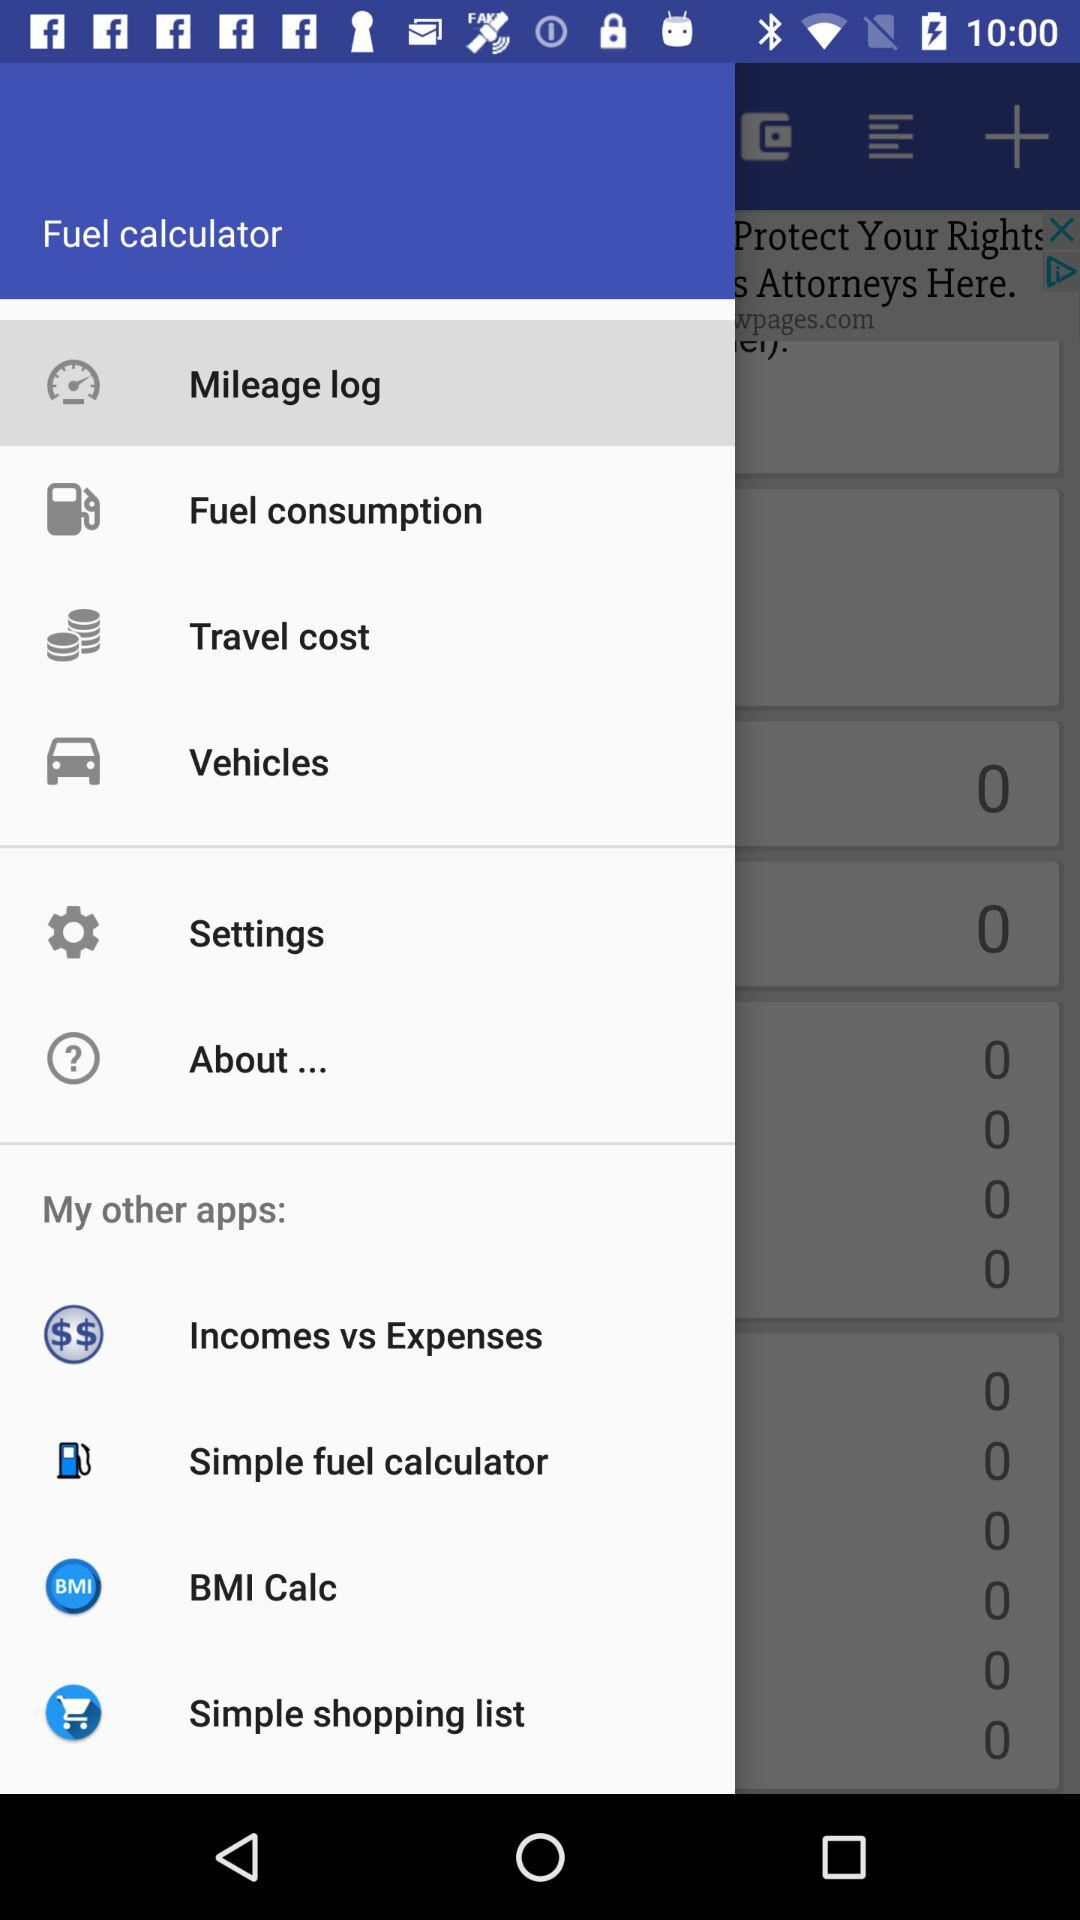What are the available items? The available items are "Mileage log", "Fuel consumption", "Travel cost", "Vehicles", "Settings", "About...", "Incomes vs Expenses", "Simple fuel calculator", "BMI Calc" and "Simple shopping list". 